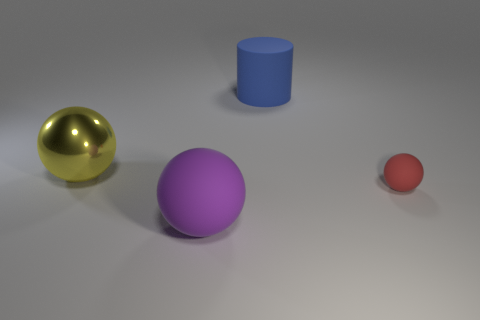Add 3 big purple matte spheres. How many objects exist? 7 Subtract all balls. How many objects are left? 1 Subtract 0 green cubes. How many objects are left? 4 Subtract all blocks. Subtract all red objects. How many objects are left? 3 Add 1 metallic things. How many metallic things are left? 2 Add 2 blue objects. How many blue objects exist? 3 